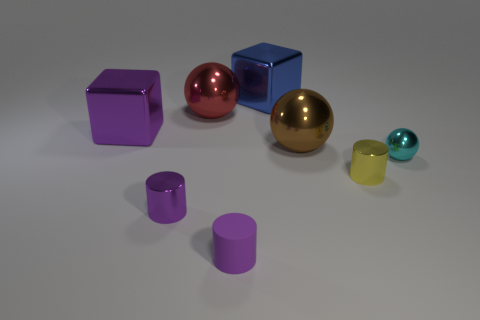How big is the metallic cube that is behind the purple shiny thing that is behind the tiny object right of the yellow metal thing?
Your response must be concise. Large. There is a brown ball that is the same material as the cyan object; what size is it?
Ensure brevity in your answer.  Large. Do the blue object and the purple metallic thing in front of the small cyan thing have the same size?
Offer a very short reply. No. There is another small purple thing that is the same shape as the small purple metal object; what is it made of?
Provide a short and direct response. Rubber. There is a block that is on the right side of the big red sphere; is it the same size as the purple metal thing in front of the big brown metal sphere?
Give a very brief answer. No. What is the shape of the red thing that is made of the same material as the purple block?
Provide a short and direct response. Sphere. What number of other things are the same shape as the small rubber thing?
Provide a short and direct response. 2. How many blue things are big metallic balls or small shiny spheres?
Provide a succinct answer. 0. Does the red object have the same shape as the cyan metallic object?
Make the answer very short. Yes. Are there any tiny metal objects that are left of the small shiny object that is to the left of the matte object?
Provide a short and direct response. No. 